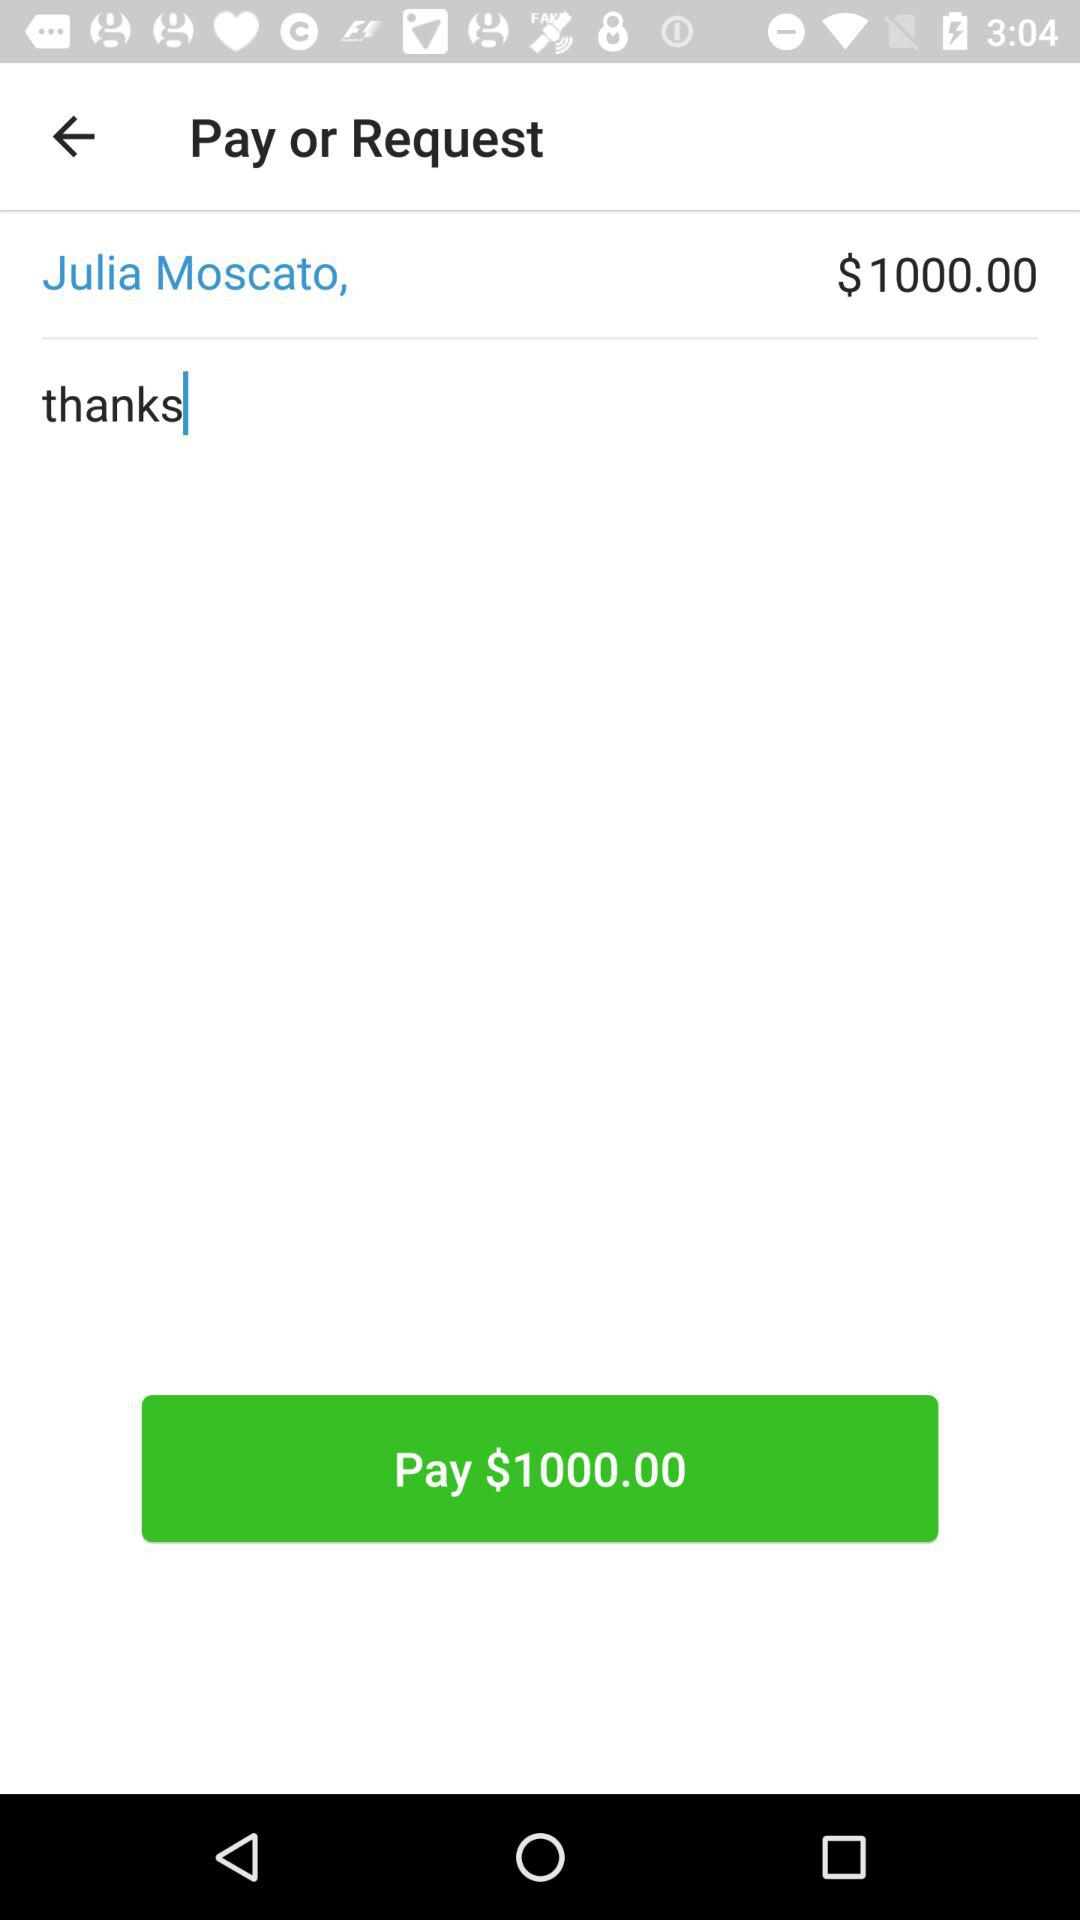When was the pay request?
When the provided information is insufficient, respond with <no answer>. <no answer> 